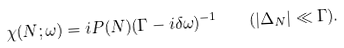Convert formula to latex. <formula><loc_0><loc_0><loc_500><loc_500>\chi ( N ; \omega ) = i P ( N ) ( \Gamma - i \delta \omega ) ^ { - 1 } \quad ( | \Delta _ { N } | \ll \Gamma ) .</formula> 